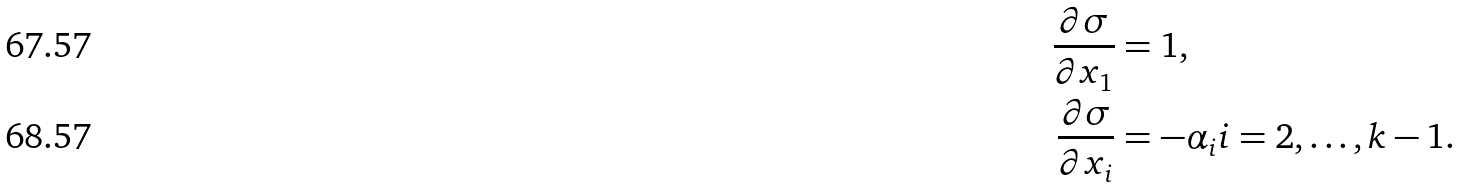<formula> <loc_0><loc_0><loc_500><loc_500>\frac { \partial \sigma } { \partial x _ { 1 } } & = 1 , \\ \frac { \partial \sigma } { \partial x _ { i } } & = - \alpha _ { i } i = 2 , \dots , k - 1 .</formula> 